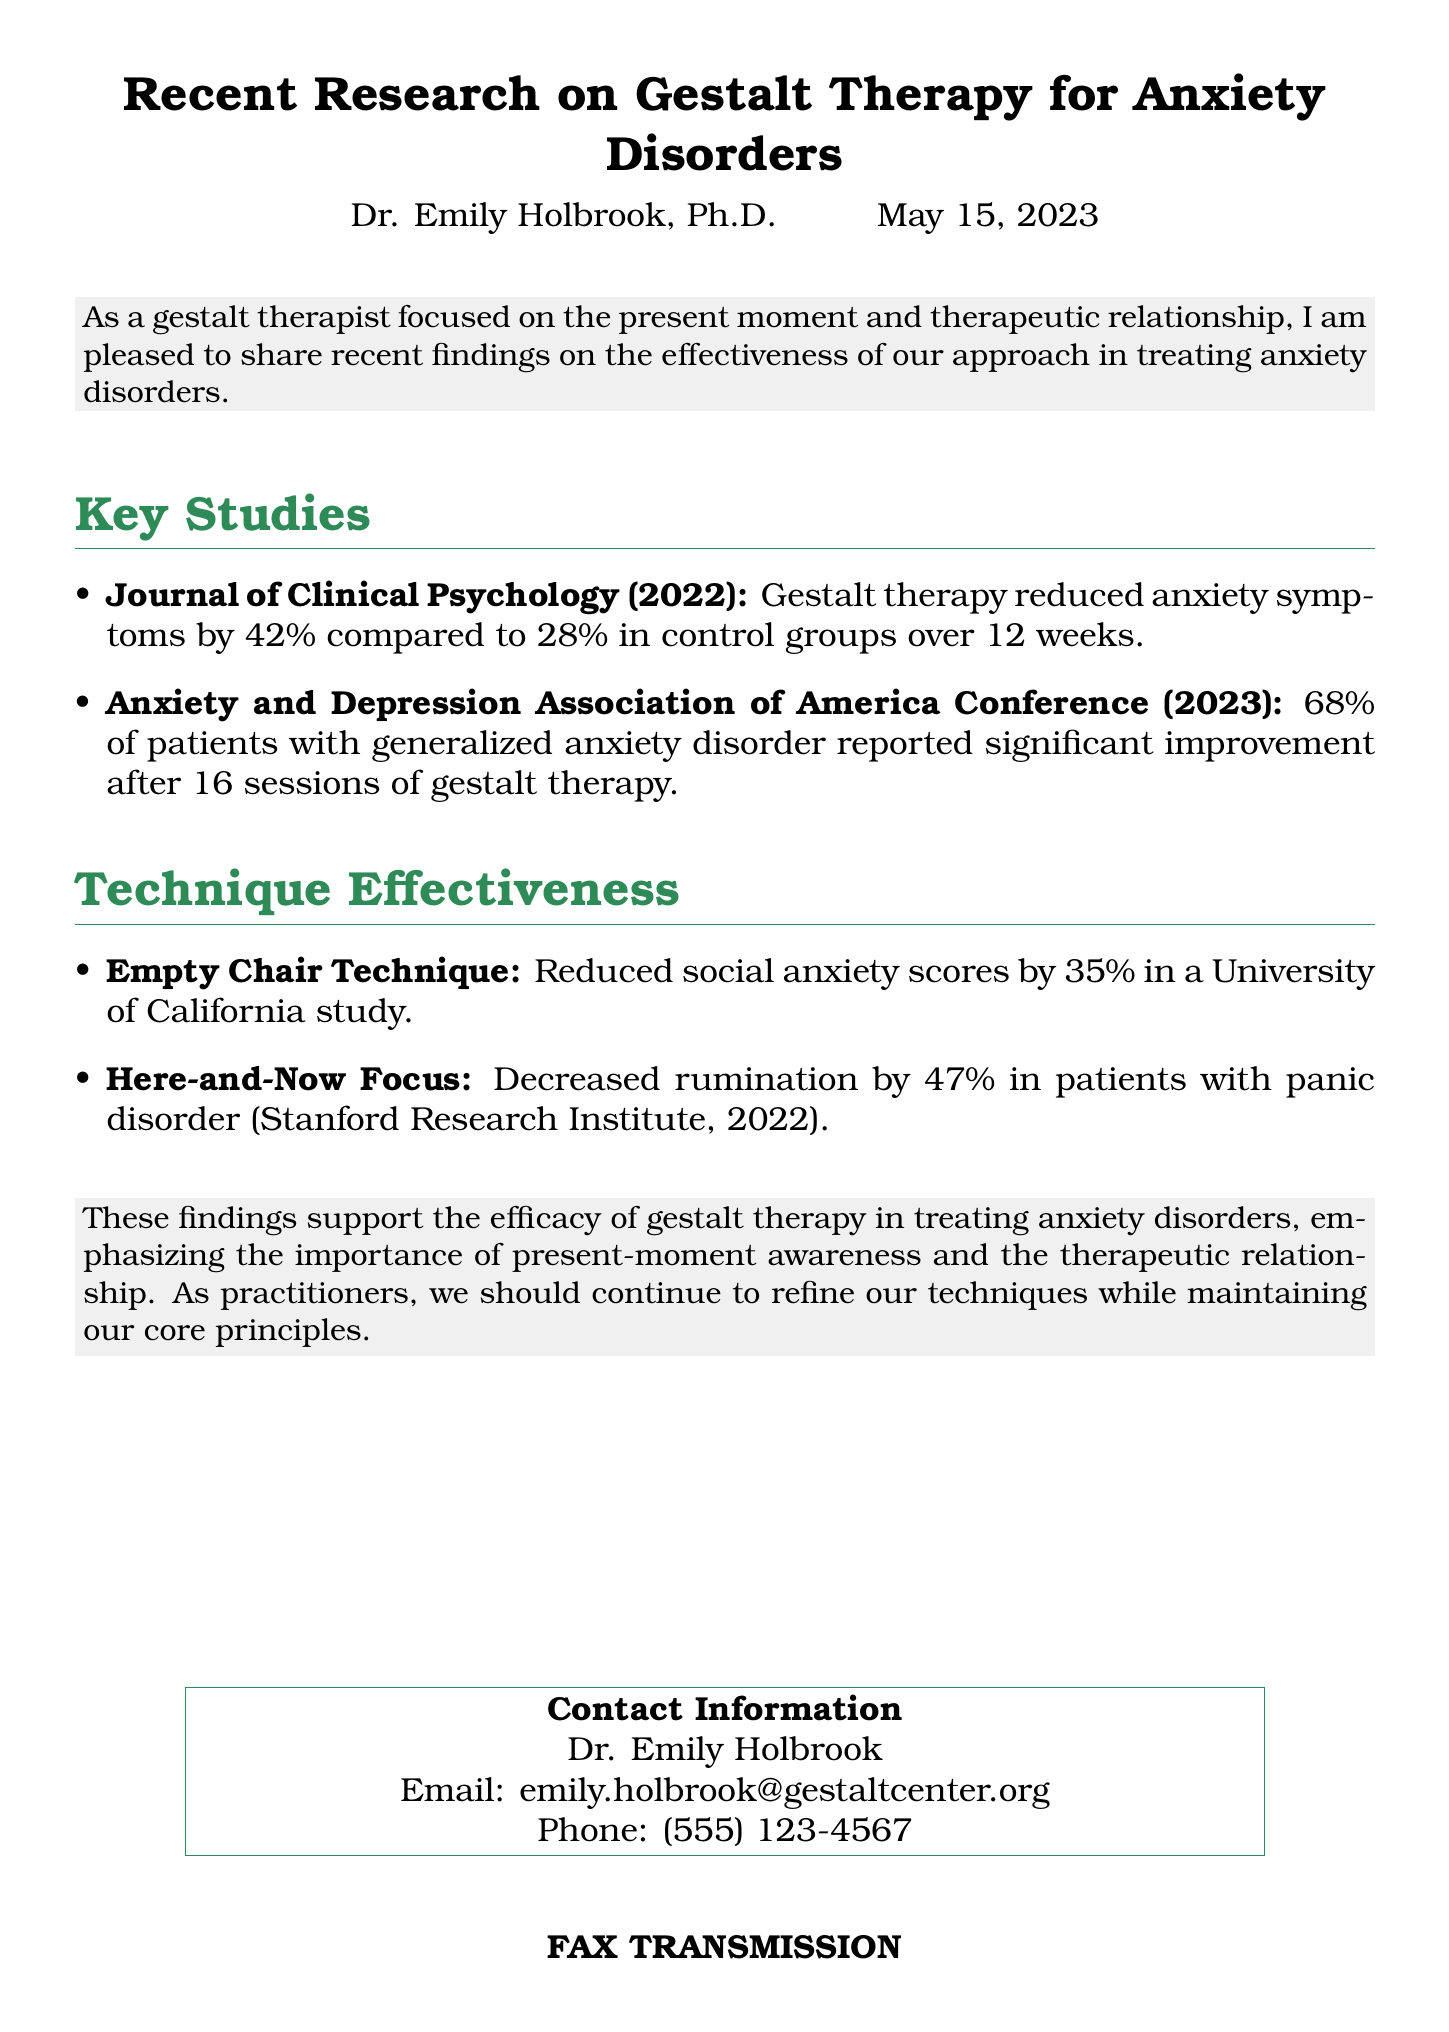what is the percentage reduction in anxiety symptoms according to the Journal of Clinical Psychology study? The document states that gestalt therapy reduced anxiety symptoms by 42%.
Answer: 42% how many sessions were reported to show significant improvement in patients with generalized anxiety disorder? It mentions that 68% of patients reported significant improvement after 16 sessions.
Answer: 16 sessions which therapeutic technique reduced social anxiety scores by 35%? The document specifies that the Empty Chair Technique achieved this reduction.
Answer: Empty Chair Technique what was the percentage decrease in rumination for patients with panic disorder? The Stanford Research Institute study revealed a decrease of 47% in rumination.
Answer: 47% who is the author of the document? The document attributes authorship to Dr. Emily Holbrook, Ph.D.
Answer: Dr. Emily Holbrook what was the control group’s percentage reduction in anxiety symptoms over 12 weeks according to the Journal of Clinical Psychology? The control group had a 28% reduction in anxiety symptoms.
Answer: 28% when was the document published? The document indicates it was published on May 15, 2023.
Answer: May 15, 2023 what is the primary focus of gestalt therapy mentioned in this fax? The document highlights present-moment awareness and the therapeutic relationship.
Answer: Present-moment awareness and the therapeutic relationship 